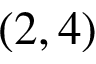<formula> <loc_0><loc_0><loc_500><loc_500>( 2 , 4 )</formula> 